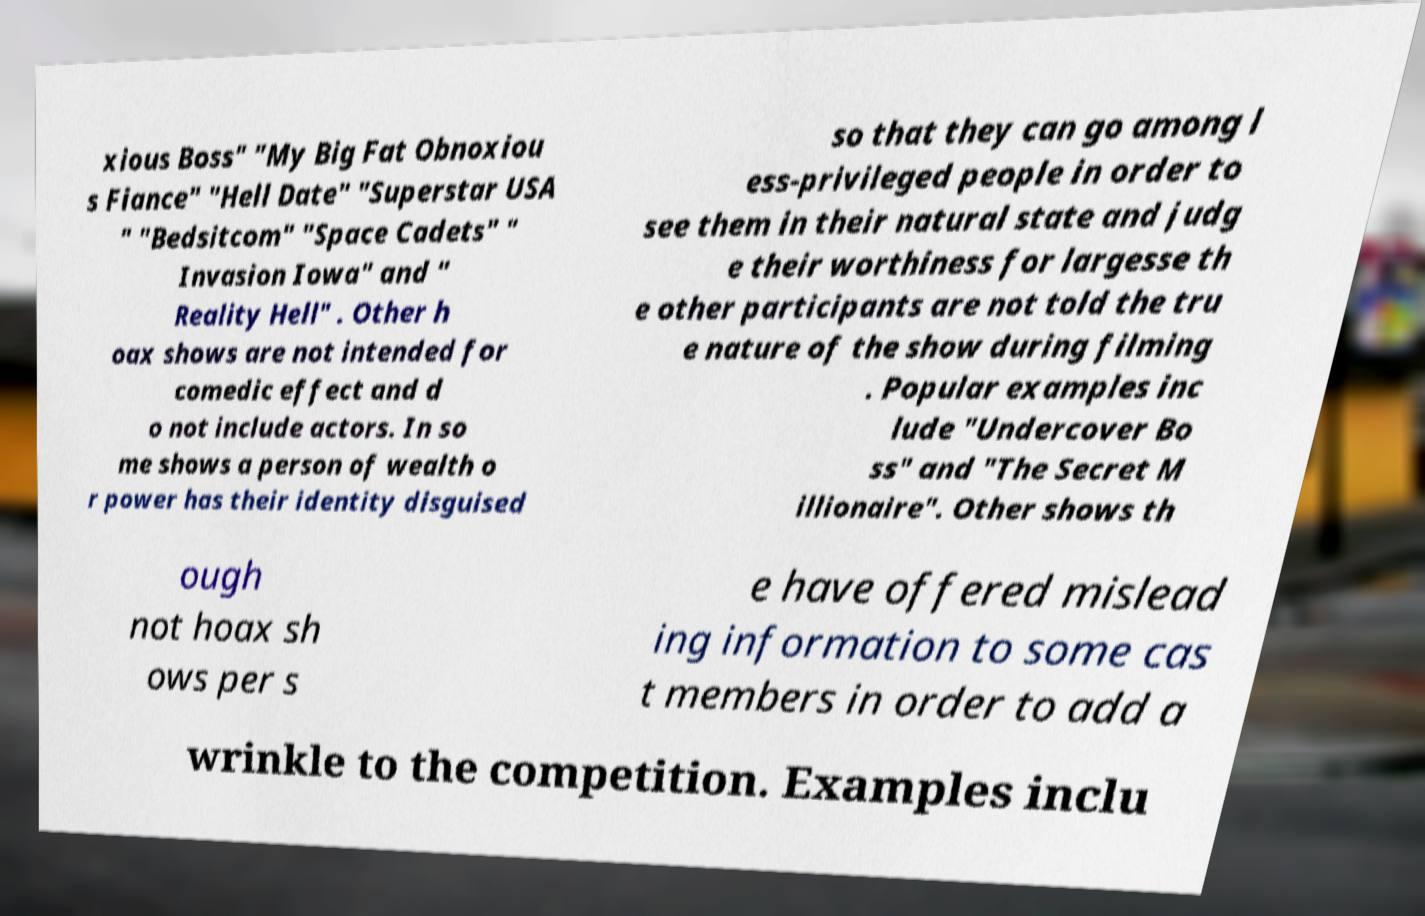Can you read and provide the text displayed in the image?This photo seems to have some interesting text. Can you extract and type it out for me? xious Boss" "My Big Fat Obnoxiou s Fiance" "Hell Date" "Superstar USA " "Bedsitcom" "Space Cadets" " Invasion Iowa" and " Reality Hell" . Other h oax shows are not intended for comedic effect and d o not include actors. In so me shows a person of wealth o r power has their identity disguised so that they can go among l ess-privileged people in order to see them in their natural state and judg e their worthiness for largesse th e other participants are not told the tru e nature of the show during filming . Popular examples inc lude "Undercover Bo ss" and "The Secret M illionaire". Other shows th ough not hoax sh ows per s e have offered mislead ing information to some cas t members in order to add a wrinkle to the competition. Examples inclu 